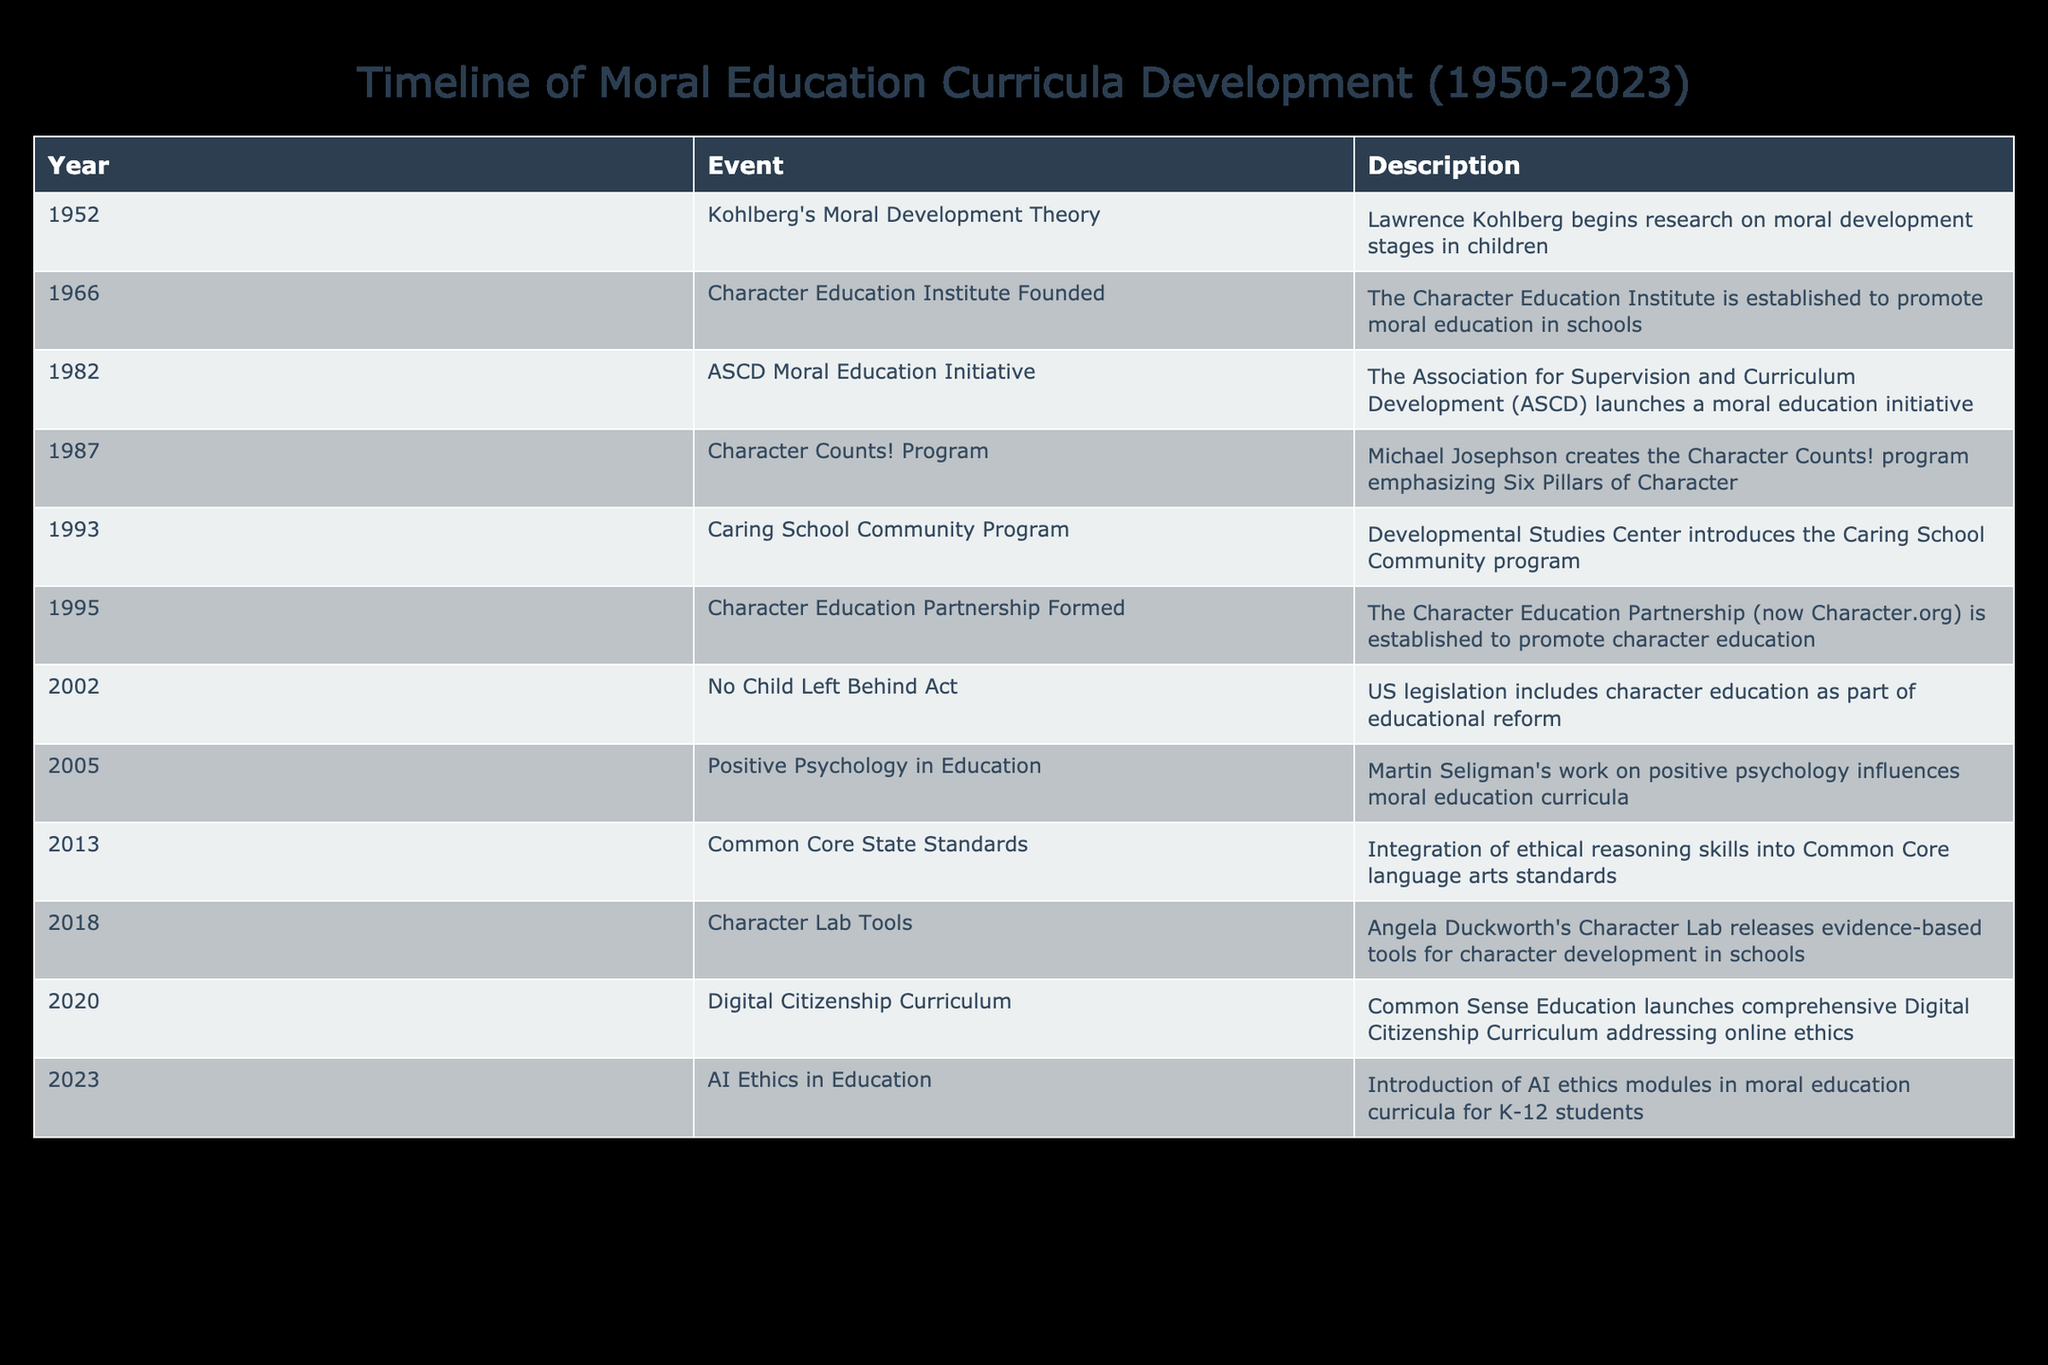What year did the Character Education Partnership get established? The table shows that the Character Education Partnership was formed in 1995. By directly looking at the 'Year' column for the corresponding 'Event', we find the answer.
Answer: 1995 Which program aimed at character development was created in 1987? From the table, we can see that the Character Counts! Program, created by Michael Josephson, is listed under the year 1987. This name directly corresponds to the event described.
Answer: Character Counts! Program How many years passed between the founding of the Character Education Institute and the launch of the ASCD Moral Education Initiative? The Character Education Institute was established in 1966 and the ASCD Moral Education Initiative launched in 1982. To find the years between them, we subtract: 1982 - 1966 = 16 years.
Answer: 16 years Was the No Child Left Behind Act related to moral education? The table indicates that the No Child Left Behind Act, enacted in 2002, includes character education as part of educational reform, which supports the view that it is related to moral education.
Answer: Yes Which event occurred first: the introduction of AI Ethics in Education or the launch of the Digital Citizenship Curriculum? According to the timeline, the Digital Citizenship Curriculum was launched in 2020, while AI Ethics in Education was introduced in 2023. Since 2020 is before 2023, the Digital Citizenship Curriculum occurred first.
Answer: Digital Citizenship Curriculum What is the total number of events listed in the timeline from 1952 to 2023? By counting the number of events listed in the table, we find a total of 12 events spanning from 1952 to 2023. This involves reviewing the number of rows in the table, which represents distinct events.
Answer: 12 What were the two initiatives related to character education that occurred in the 2000s? From the timeline, the two initiatives related to character education in the 2000s include the No Child Left Behind Act in 2002 and Positive Psychology in Education in 2005. These are found by filtering the events that happened in the years between 2000 and 2009.
Answer: No Child Left Behind Act and Positive Psychology in Education What was the focus of the Caring School Community Program introduced in 1993? The description for the Caring School Community Program in 1993 indicates its primary focus on fostering caring relationships and community within schools, promoting a moral and supportive learning environment. This is interpreted directly from the description provided in the table.
Answer: Caring relationships and community in schools Which initiative was influenced by Martin Seligman's work? The table indicates that Positive Psychology in Education, launched in 2005, was influenced by Martin Seligman's work on positive psychology. This can be determined by examining the description associated with that specific event.
Answer: Positive Psychology in Education 